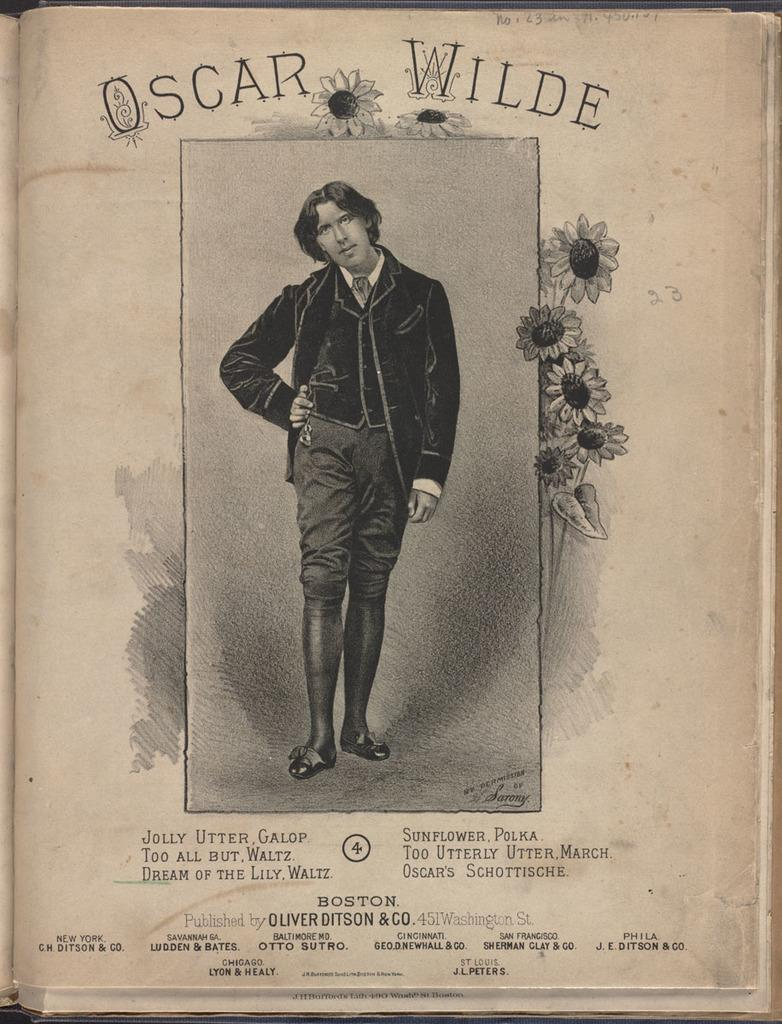What is the main subject of the image? There is a person standing in the image. What can be seen in the background or surrounding the person? There are flowers in the image. Is there any text or writing present in the image? Yes, there is something written in the image. How does the person taste the flowers in the image? There is no indication in the image that the person is tasting the flowers, and therefore no such action can be observed. 